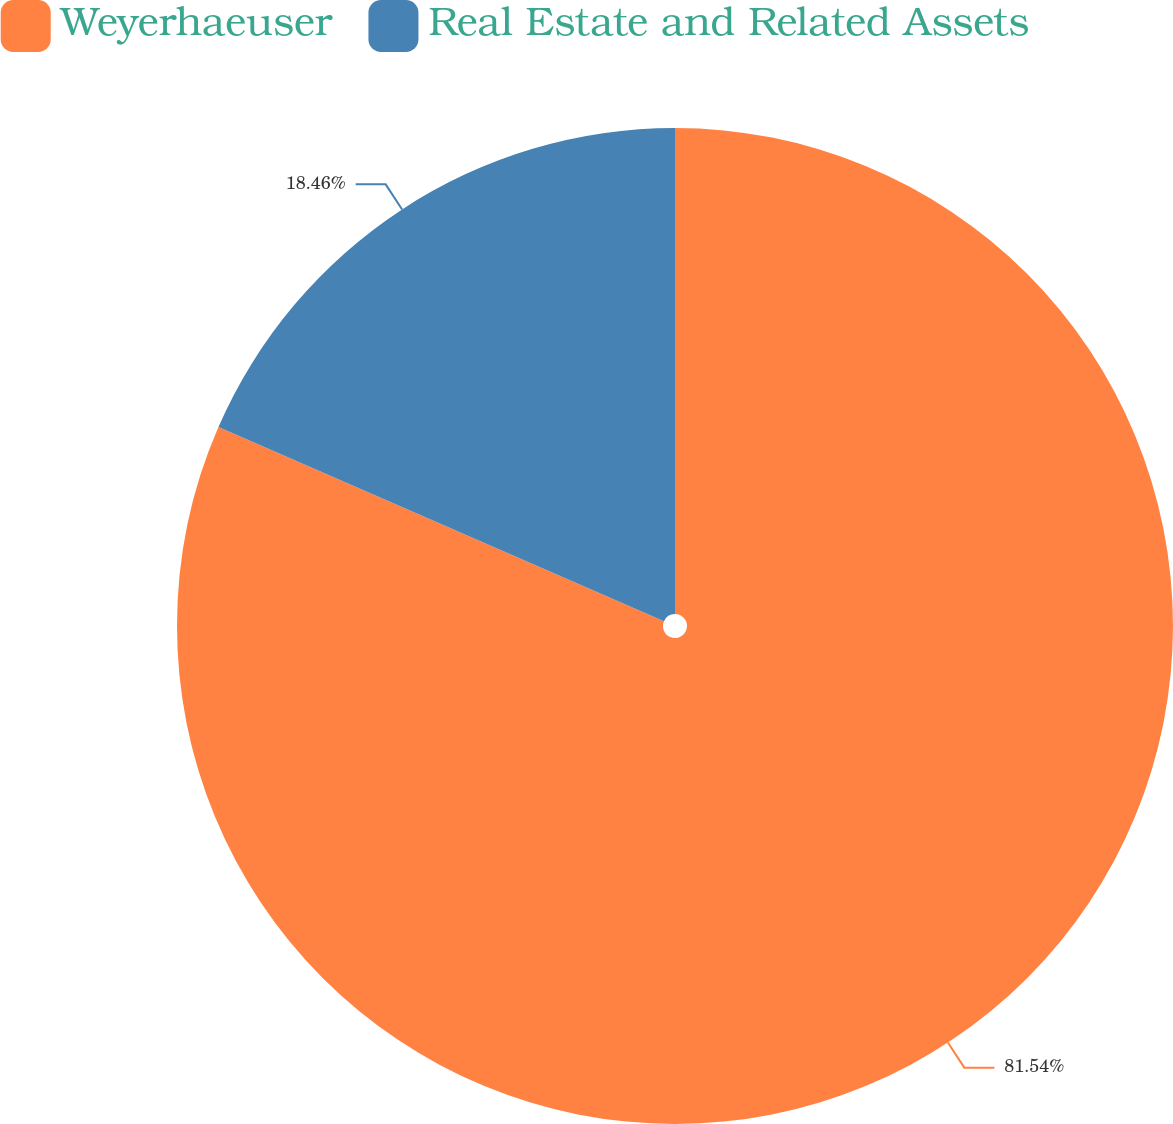Convert chart to OTSL. <chart><loc_0><loc_0><loc_500><loc_500><pie_chart><fcel>Weyerhaeuser<fcel>Real Estate and Related Assets<nl><fcel>81.54%<fcel>18.46%<nl></chart> 